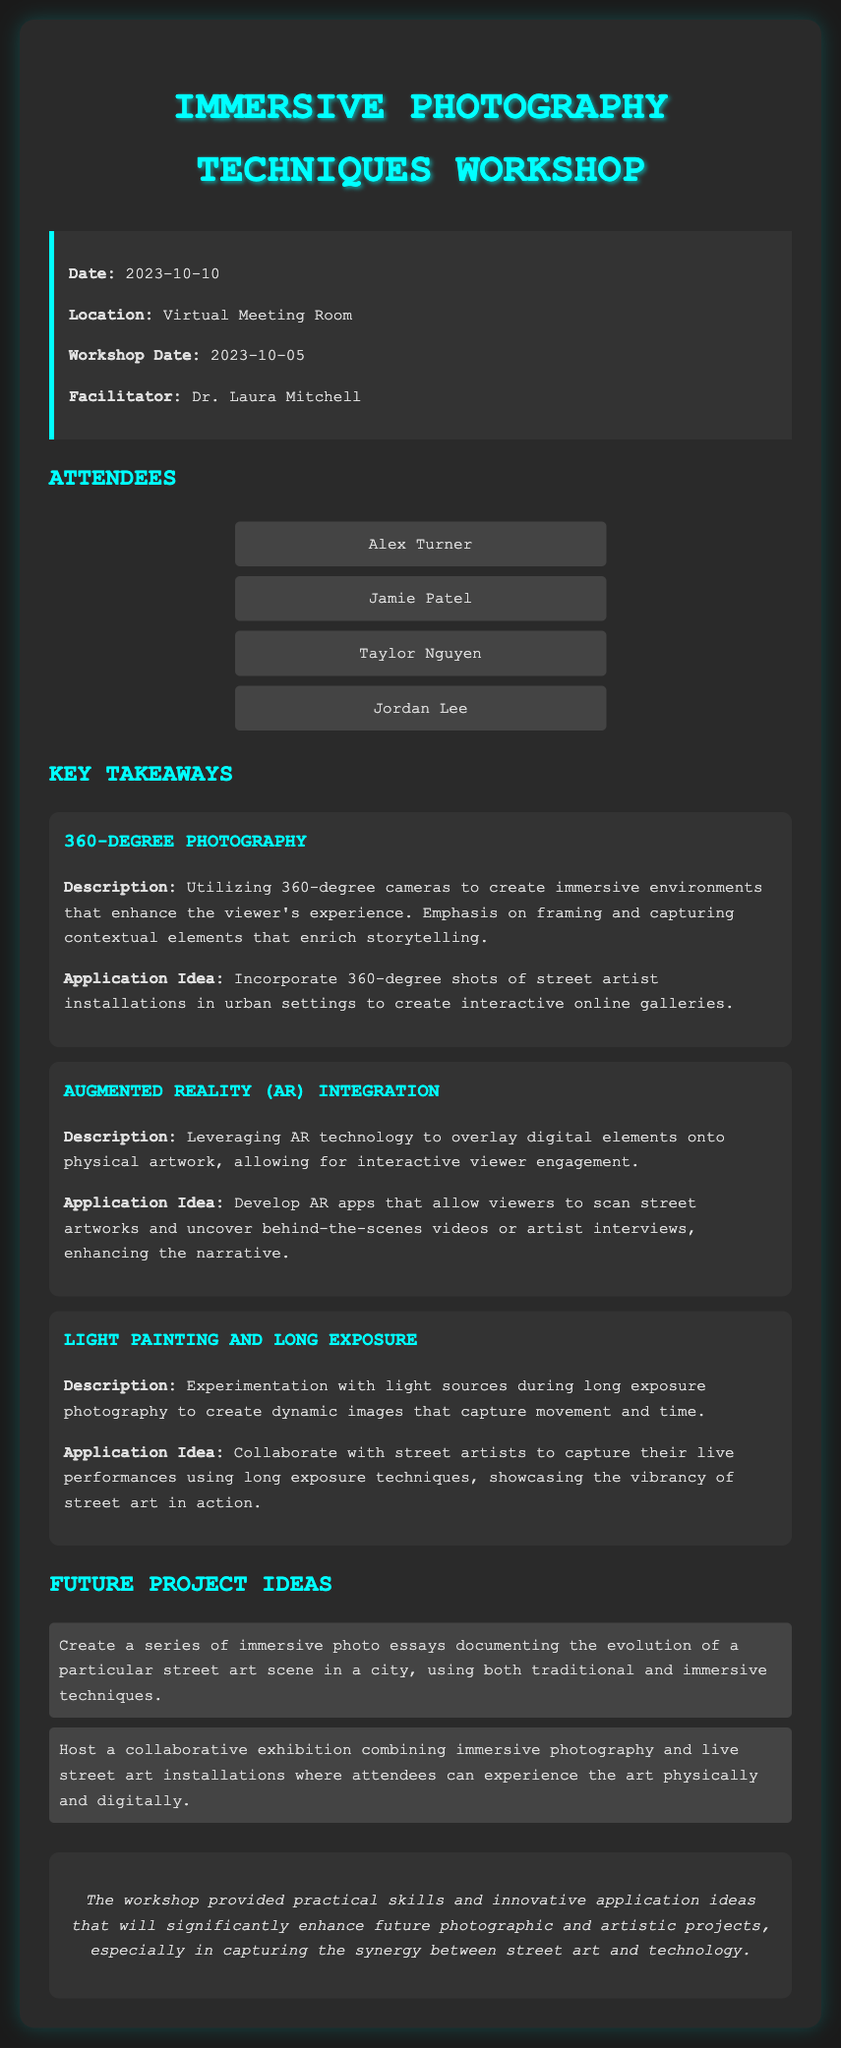What date was the workshop held? The date mentioned for the workshop is 2023-10-05.
Answer: 2023-10-05 Who facilitated the workshop? The facilitator of the workshop is Dr. Laura Mitchell.
Answer: Dr. Laura Mitchell What technique focuses on capturing immersive environments? The technique that focuses on capturing immersive environments is 360-Degree Photography.
Answer: 360-Degree Photography What is one application idea for AR Integration? One application idea for AR Integration is to develop AR apps that allow viewers to scan street artworks.
Answer: Develop AR apps to scan street artworks How many attendees are listed in the document? There are four attendees listed in the document.
Answer: Four What type of photography uses light sources during long exposure? The type of photography that uses light sources during long exposure is Light Painting and Long Exposure.
Answer: Light Painting and Long Exposure What is one future project idea mentioned? One future project idea mentioned is to create a series of immersive photo essays.
Answer: Create a series of immersive photo essays What was the location of the meeting? The location of the meeting was a Virtual Meeting Room.
Answer: Virtual Meeting Room What is the color theme used in the document? The color theme used in the document primarily involves dark tones with cyan accents.
Answer: Dark tones with cyan accents 